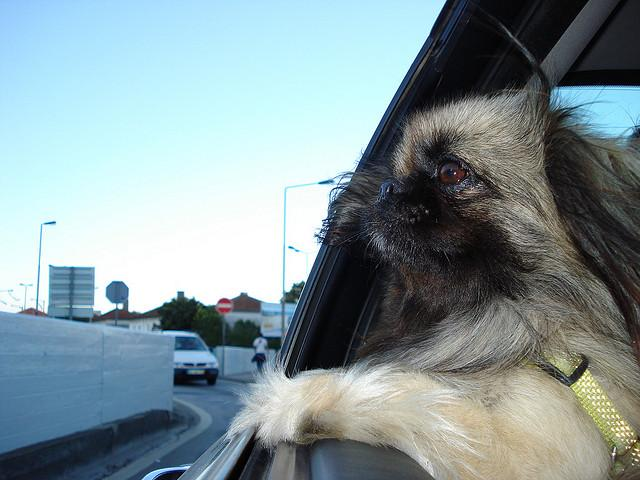What kind of pet is looking out the window? dog 